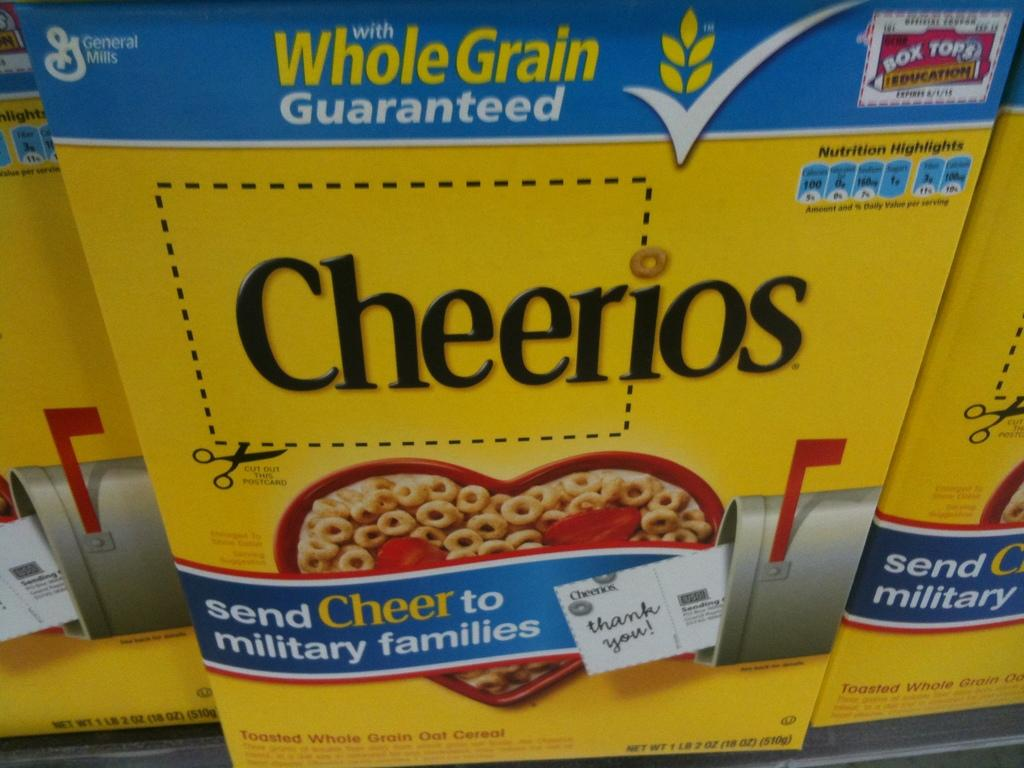<image>
Write a terse but informative summary of the picture. A yellow box of Cheerios sits on a shelf. 